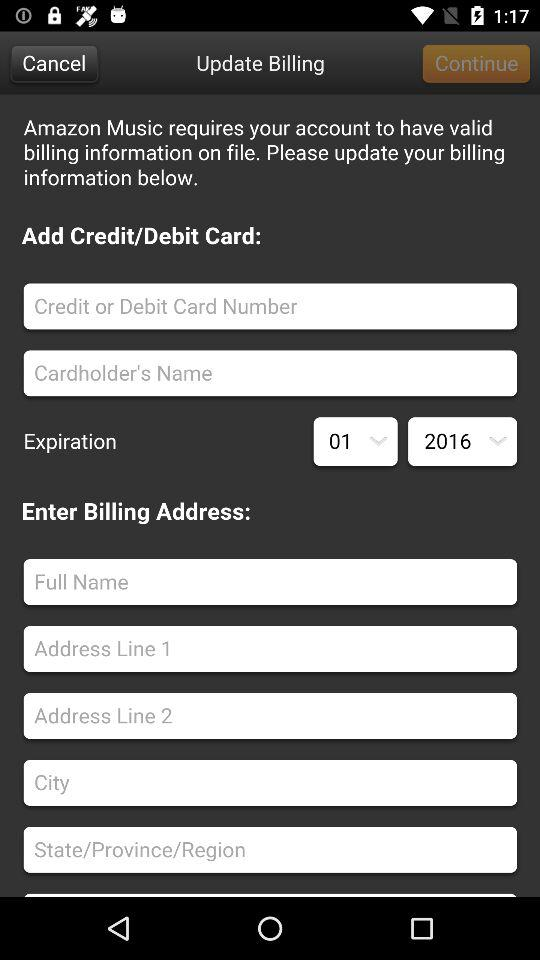What is the expiration month and year? The expiration month and year are January and 2016, respectively. 